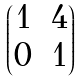Convert formula to latex. <formula><loc_0><loc_0><loc_500><loc_500>\begin{pmatrix} 1 & 4 \\ 0 & 1 \end{pmatrix}</formula> 